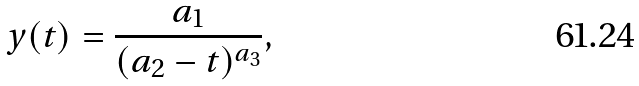Convert formula to latex. <formula><loc_0><loc_0><loc_500><loc_500>y ( t ) = \frac { a _ { 1 } } { ( a _ { 2 } - t ) ^ { a _ { 3 } } } ,</formula> 